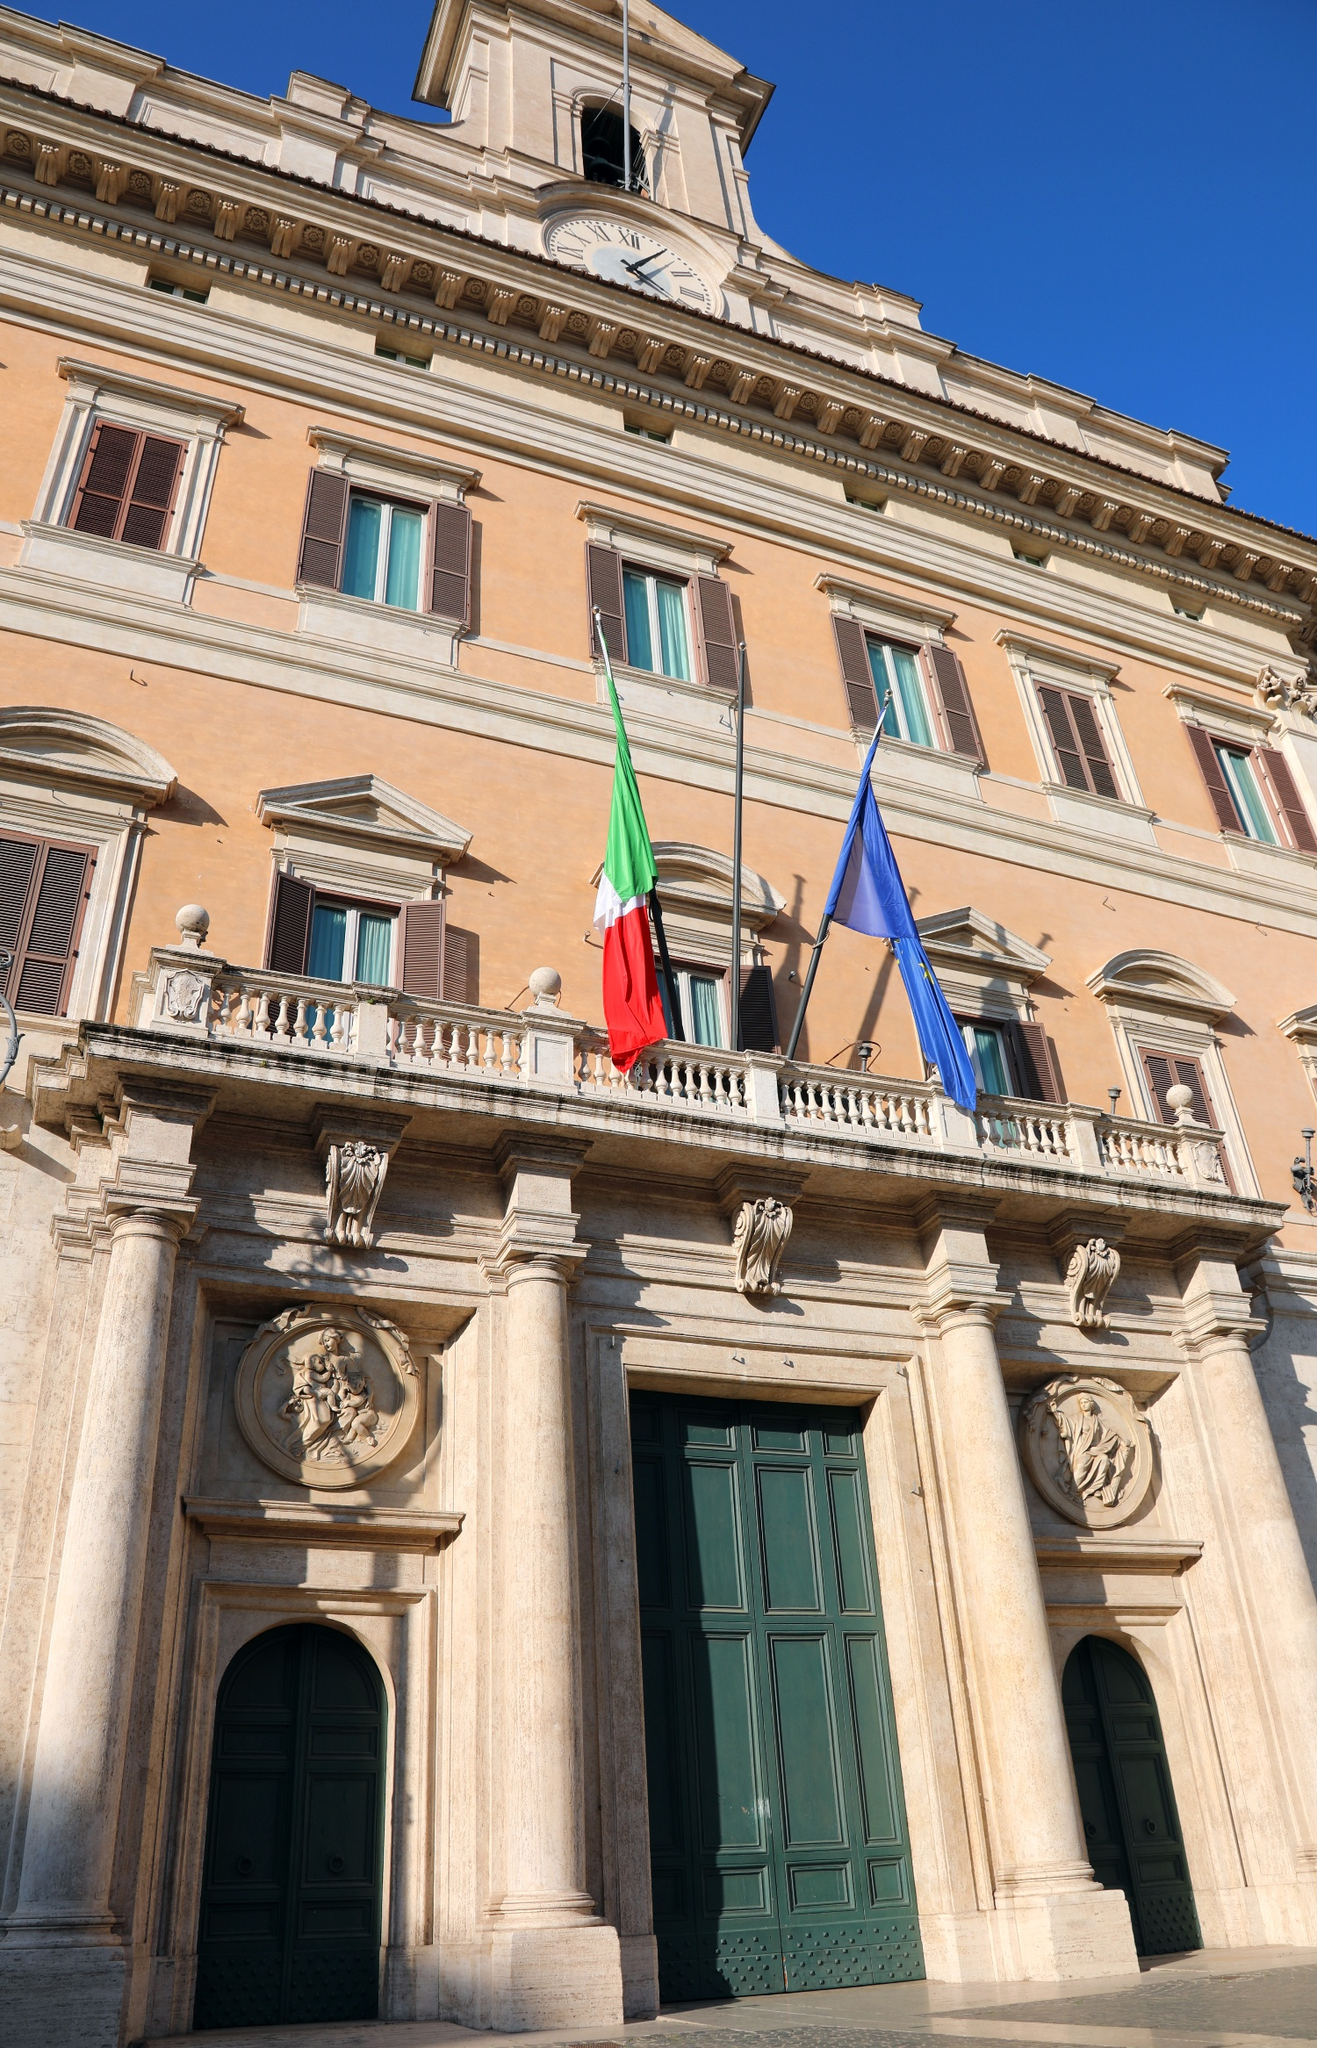Discuss the significance of the flags seen in the image. The flags displayed prominently in the image are the Italian national flag and the European Union flag. The Italian flag, with its vertical tricolor of green, white, and red, is a powerful symbol of the nation's identity and unity. It represents Italy's republican democracy and its values. The European Union flag, featuring a circle of twelve golden stars on a blue background, signifies Italy's membership in the EU, reflecting its commitment to European solidarity, cooperation, and peace. Together, these flags not only denote sovereignty and national pride but also Italy's integral role within the broader European community. 